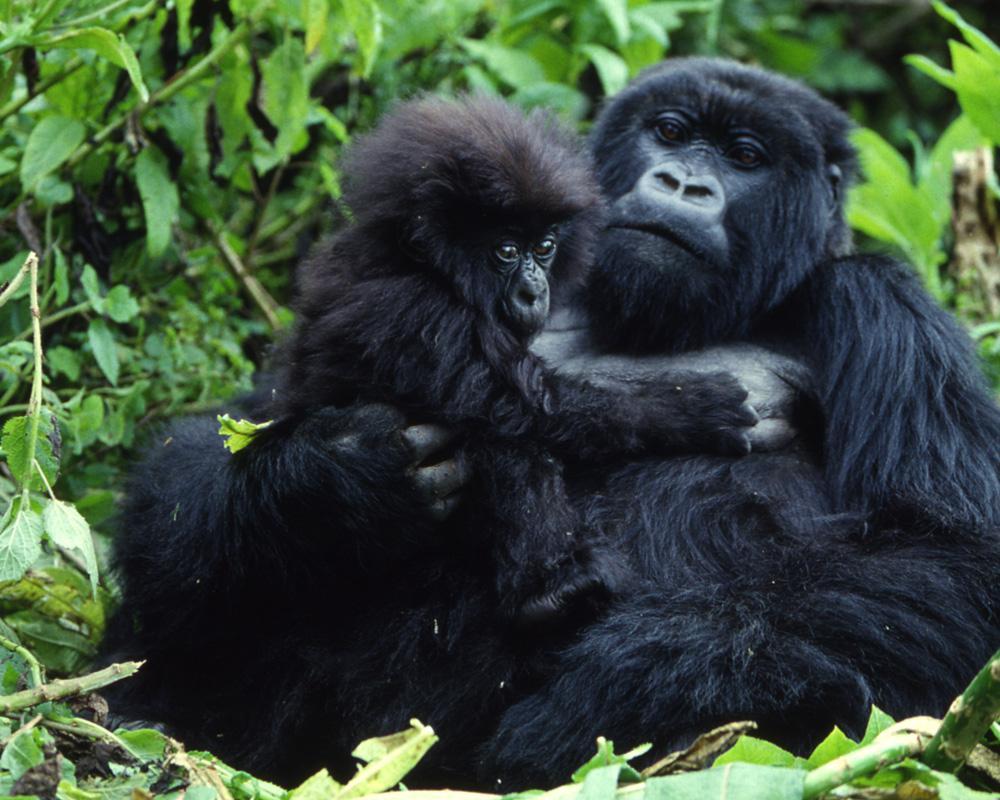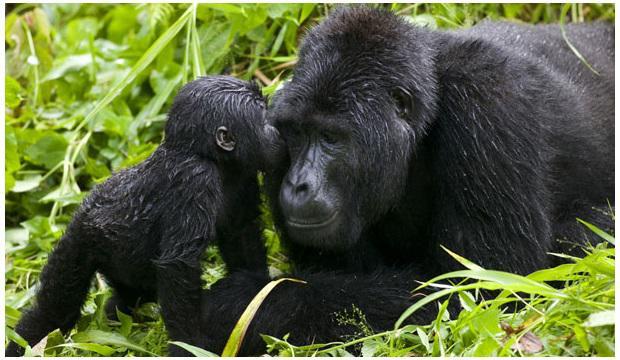The first image is the image on the left, the second image is the image on the right. Examine the images to the left and right. Is the description "There are a total of 5 gorillas with one being a baby being elevated off of the ground by an adult gorilla." accurate? Answer yes or no. No. 